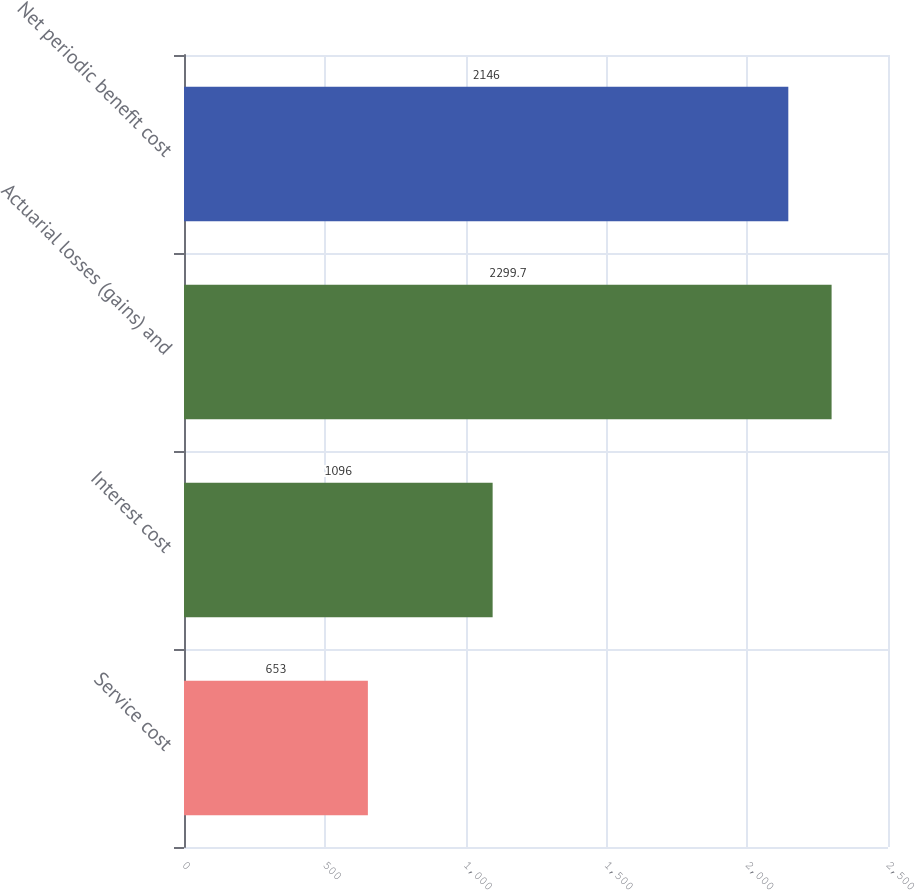Convert chart. <chart><loc_0><loc_0><loc_500><loc_500><bar_chart><fcel>Service cost<fcel>Interest cost<fcel>Actuarial losses (gains) and<fcel>Net periodic benefit cost<nl><fcel>653<fcel>1096<fcel>2299.7<fcel>2146<nl></chart> 